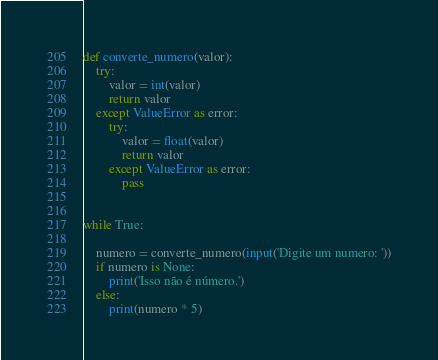Convert code to text. <code><loc_0><loc_0><loc_500><loc_500><_Python_>
def converte_numero(valor):
    try:
        valor = int(valor)
        return valor
    except ValueError as error:
        try:
            valor = float(valor)
            return valor
        except ValueError as error:
            pass


while True:

    numero = converte_numero(input('Digite um numero: '))
    if numero is None:
        print('Isso não é número.')
    else:
        print(numero * 5)
</code> 